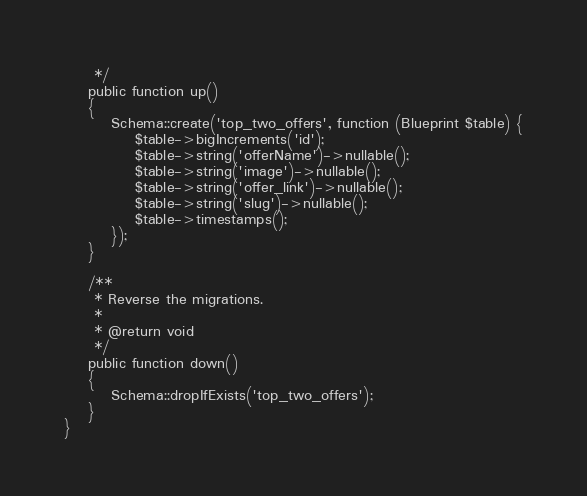<code> <loc_0><loc_0><loc_500><loc_500><_PHP_>     */
    public function up()
    {
        Schema::create('top_two_offers', function (Blueprint $table) {
            $table->bigIncrements('id');
            $table->string('offerName')->nullable();
            $table->string('image')->nullable();
            $table->string('offer_link')->nullable();
            $table->string('slug')->nullable();
            $table->timestamps();
        });
    }

    /**
     * Reverse the migrations.
     *
     * @return void
     */
    public function down()
    {
        Schema::dropIfExists('top_two_offers');
    }
}
</code> 